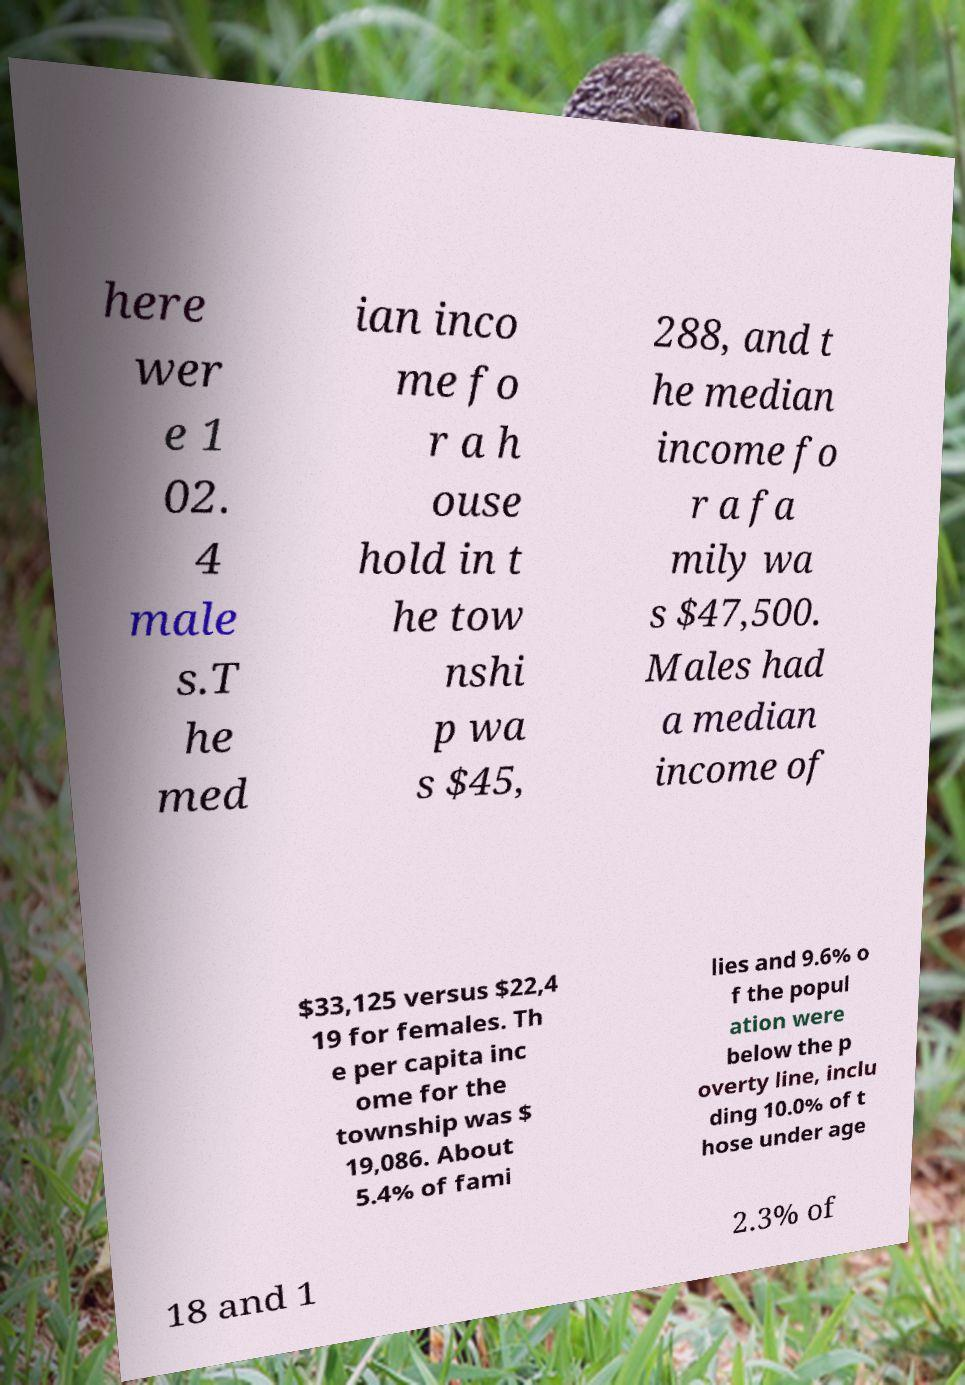What messages or text are displayed in this image? I need them in a readable, typed format. here wer e 1 02. 4 male s.T he med ian inco me fo r a h ouse hold in t he tow nshi p wa s $45, 288, and t he median income fo r a fa mily wa s $47,500. Males had a median income of $33,125 versus $22,4 19 for females. Th e per capita inc ome for the township was $ 19,086. About 5.4% of fami lies and 9.6% o f the popul ation were below the p overty line, inclu ding 10.0% of t hose under age 18 and 1 2.3% of 